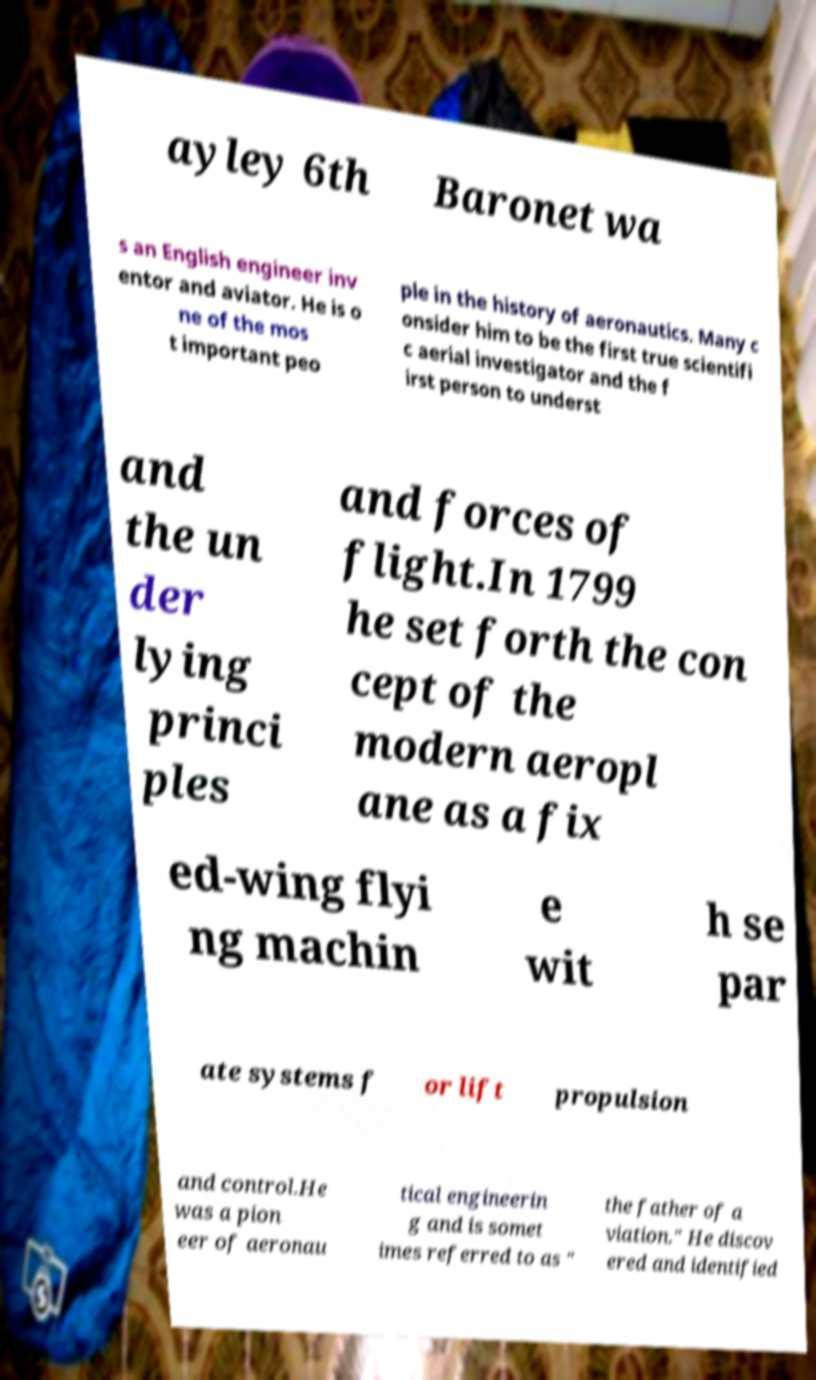Could you assist in decoding the text presented in this image and type it out clearly? ayley 6th Baronet wa s an English engineer inv entor and aviator. He is o ne of the mos t important peo ple in the history of aeronautics. Many c onsider him to be the first true scientifi c aerial investigator and the f irst person to underst and the un der lying princi ples and forces of flight.In 1799 he set forth the con cept of the modern aeropl ane as a fix ed-wing flyi ng machin e wit h se par ate systems f or lift propulsion and control.He was a pion eer of aeronau tical engineerin g and is somet imes referred to as " the father of a viation." He discov ered and identified 